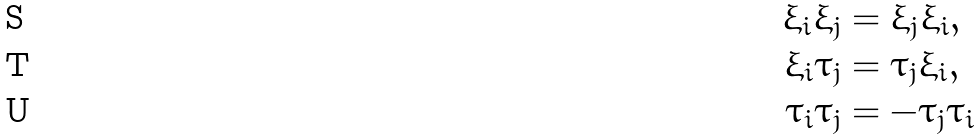<formula> <loc_0><loc_0><loc_500><loc_500>\xi _ { i } \xi _ { j } & = \xi _ { j } \xi _ { i } , \\ \xi _ { i } \tau _ { j } & = \tau _ { j } \xi _ { i } , \\ \tau _ { i } \tau _ { j } & = - \tau _ { j } \tau _ { i }</formula> 